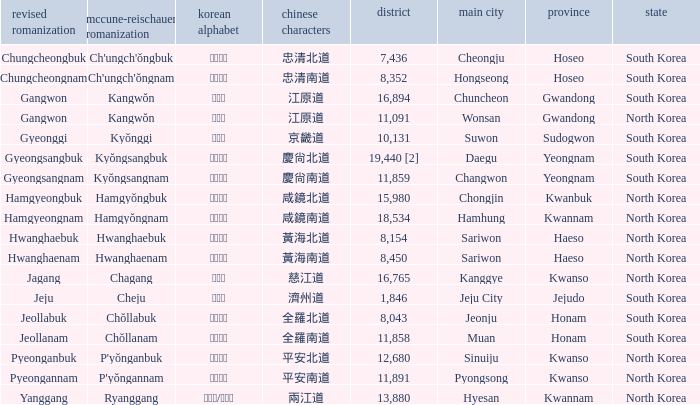Which capital has a Hangul of 경상남도? Changwon. 